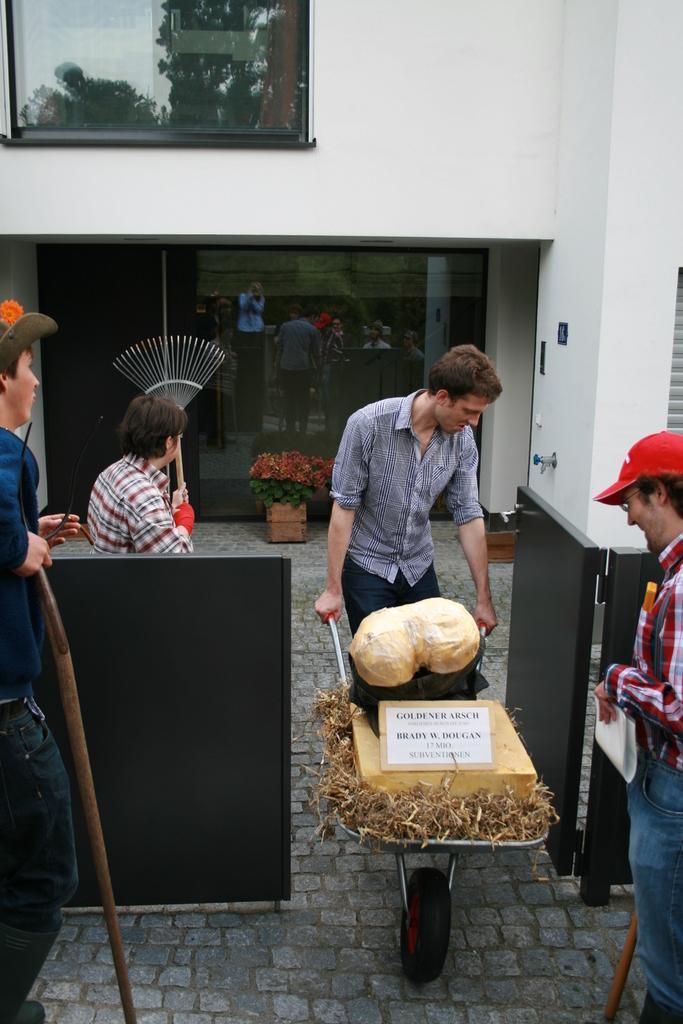Describe this image in one or two sentences. In this image we can see few people standing, a person is holding a wooden stick, a person is holding a broom stick, a person is holding a cart with few objects and a person is holding a paper and there is potted plant, a building and the reflection of trees on the glass of the building and there is a gate near the people. 